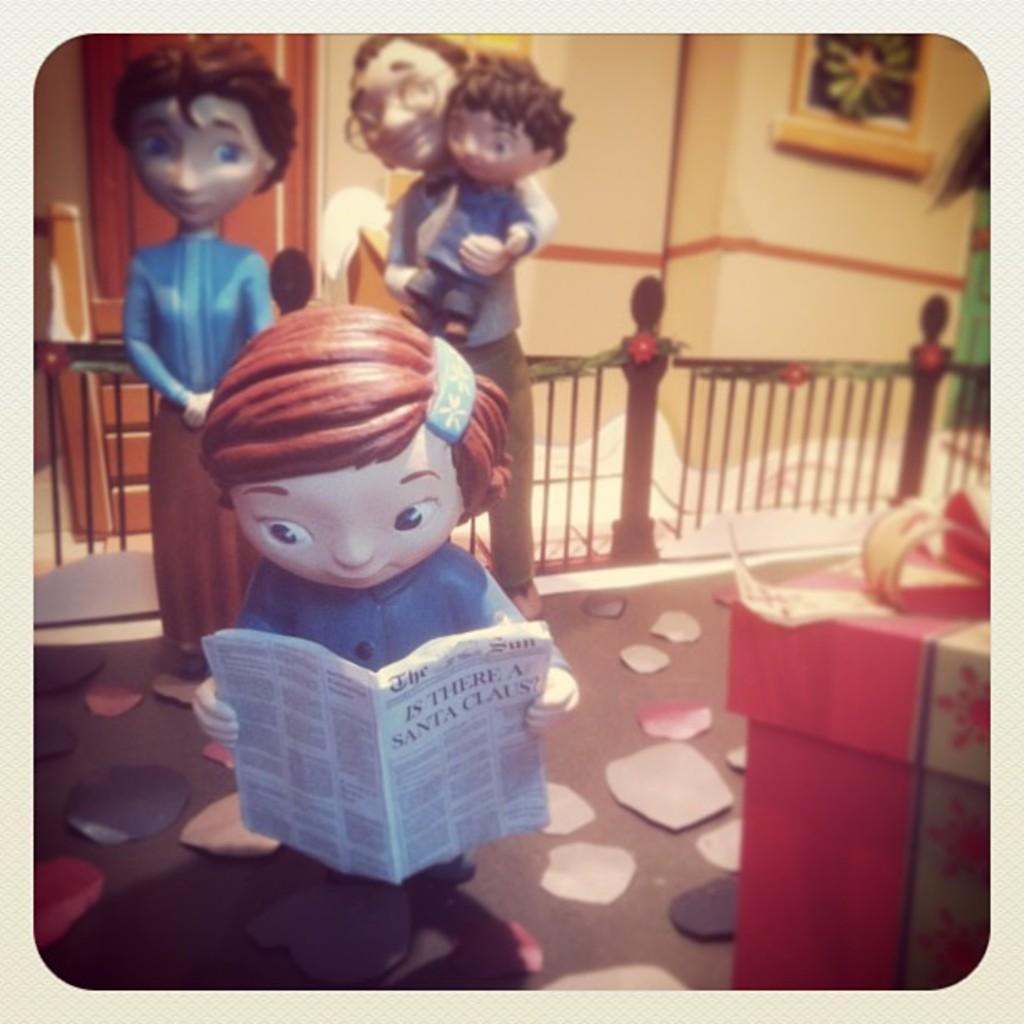Please provide a concise description of this image. This picture contains four statuettes. The statuette in front of the picture is holding a book. On the right side, we see a red color table. Behind that, we see an iron railing. Behind that, we see a door and a wall on which photo frame is placed. 